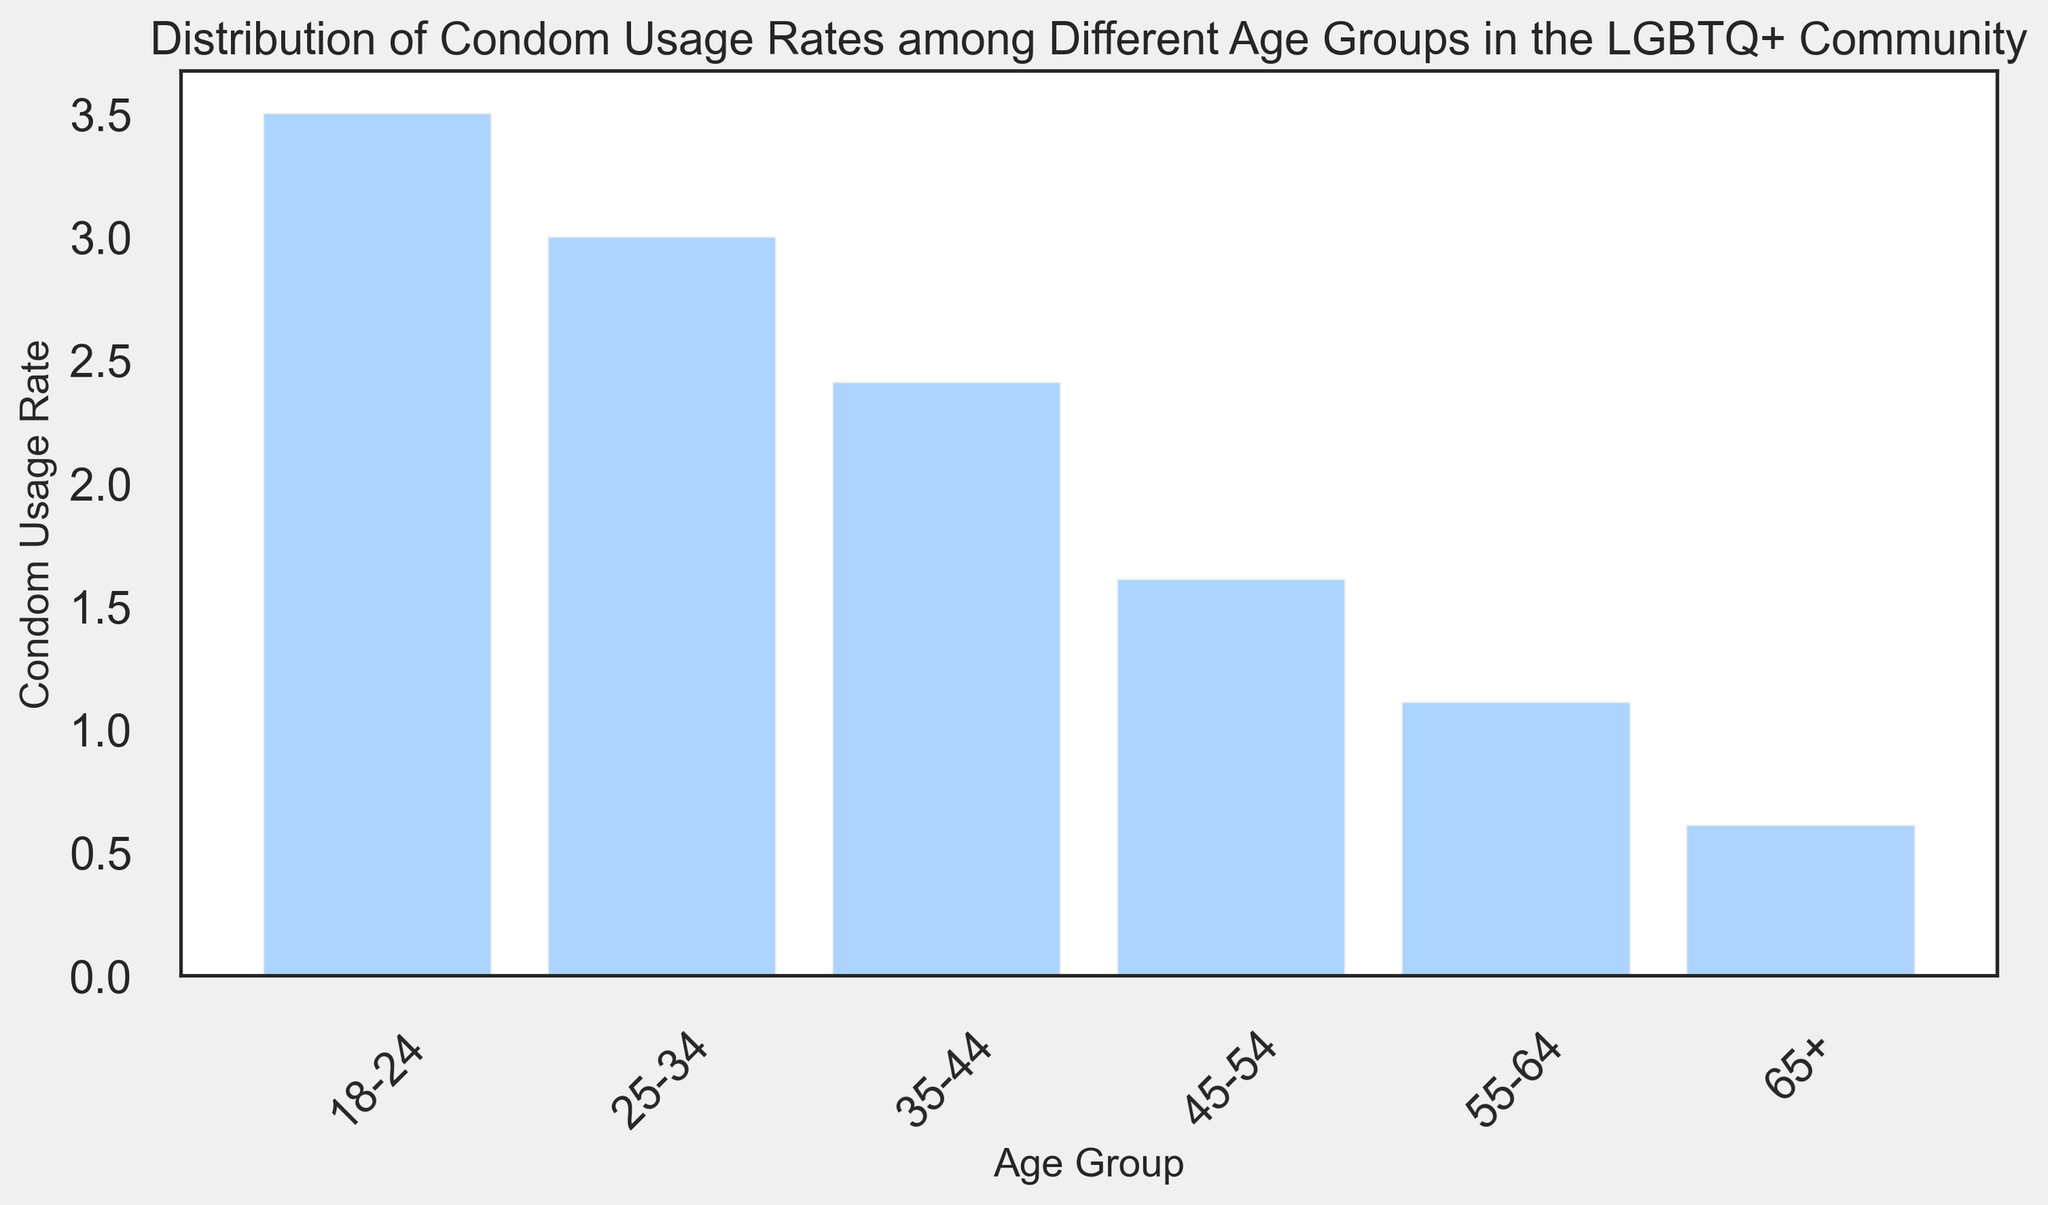What age group appears to have the highest condom usage rate in the LGBTQ+ community? The age group with the highest condom usage rate can be identified by comparing the maximum histogram bar height for each age group. The 18-24 age group has the highest bars, indicating the highest usage rates.
Answer: 18-24 Which age group has the lowest condom usage rate? The age group with the lowest condom usage rate has histogram bars with the smallest heights. The 65+ age group has the lowest bars, indicating the lowest usage rates.
Answer: 65+ How does the condom usage rate of the 25-34 age group compare to the 55-64 age group? By visually comparing the heights of the histogram bars, the bars for the 25-34 age group are higher than those for the 55-64 age group, indicating higher usage rates for the younger group.
Answer: Higher What is the general trend in condom usage rates across the different age groups? The general trend can be deduced by observing the heights of the histogram bars from left to right. The bars generally decrease, indicating that condom usage rates reduce as age increases.
Answer: Decreasing What is the average condom usage rate for the 18-24 age group? Summing the data points for the 18-24 age group (0.75, 0.65, 0.68, 0.72, 0.70) and dividing by the number of data points (5) gives the average rate. (0.75 + 0.65 + 0.68 + 0.72 + 0.70) / 5 = 3.5 / 5 = 0.70
Answer: 0.70 Is there a significant difference in condom usage rates between the 35-44 and 45-54 age groups? Visually comparing the histogram bars for these age groups, the 35-44 age group's bars are higher than the 45-54 group's bars, reflecting a significant difference.
Answer: Yes Which age group has the most uniform distribution of condom usage rates? The uniformity of the distribution can be observed by the evenness of the histogram bar heights. The 18-24 age group has similar bar heights, indicating a uniform distribution.
Answer: 18-24 What is the median condom usage rate for the 45-54 age group? Sorting the data points for the 45-54 age group (0.30, 0.31, 0.32, 0.33, 0.35) and finding the middle value gives the median rate. The middle value is 0.32.
Answer: 0.32 Is there a visual increase or decrease in condom usage rates from the 55-64 age group to the 65+ age group? By comparing the bar heights for the 55-64 and 65+ age groups, there is a visual decrease in the heights, indicating a decrease in usage rates.
Answer: Decrease 